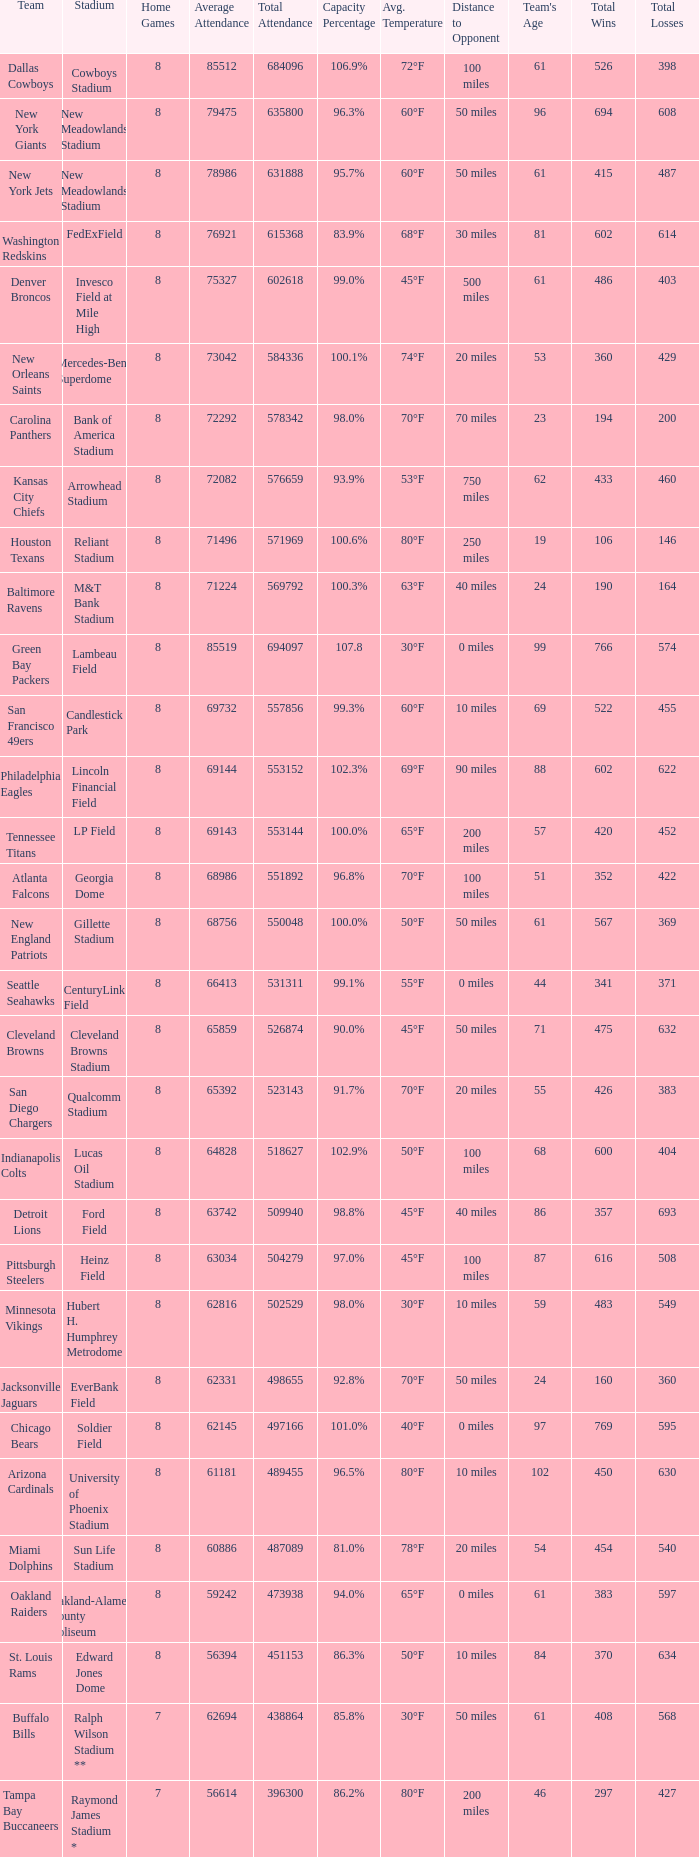What is the name of the team when the stadium is listed as Edward Jones Dome? St. Louis Rams. 